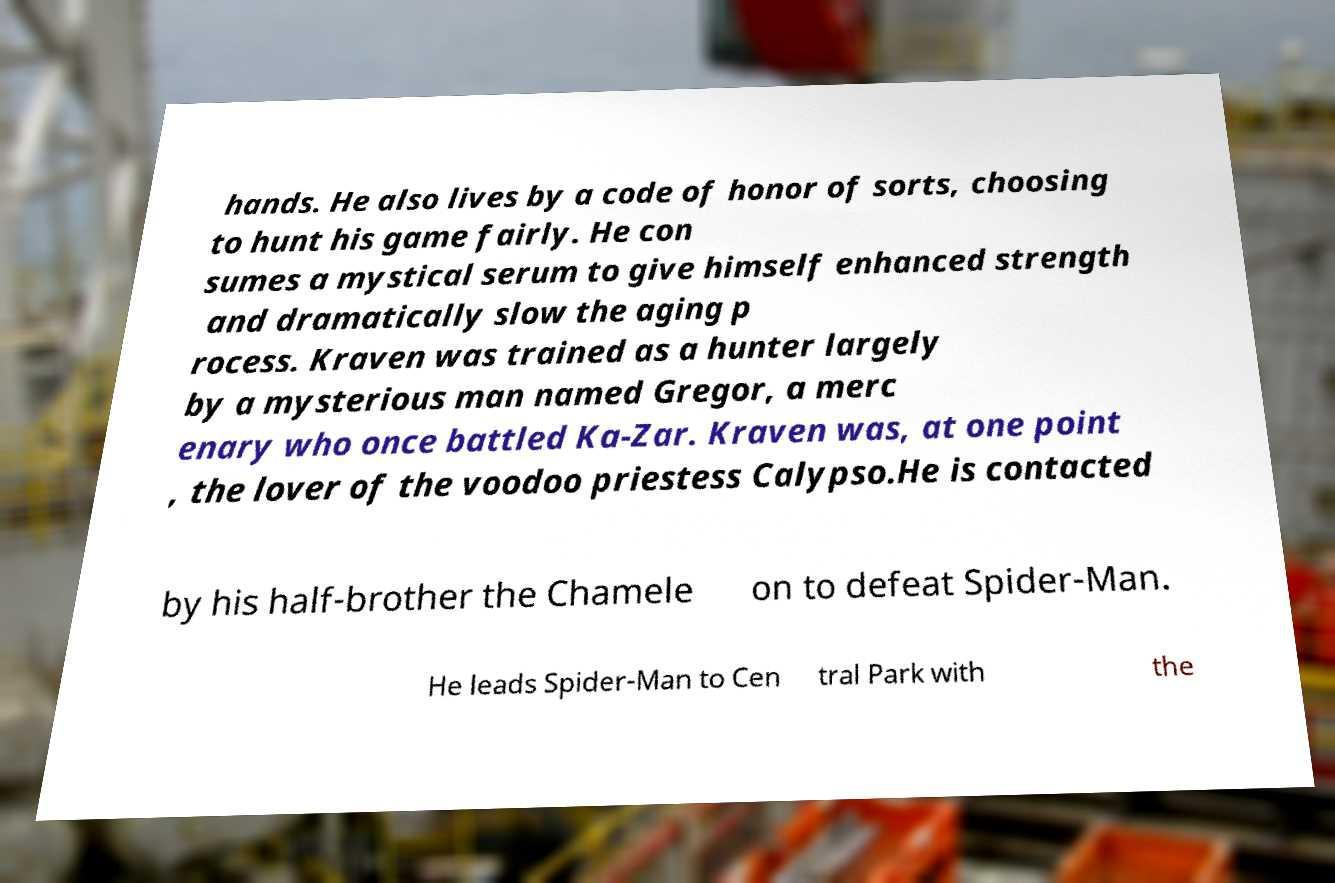Could you assist in decoding the text presented in this image and type it out clearly? hands. He also lives by a code of honor of sorts, choosing to hunt his game fairly. He con sumes a mystical serum to give himself enhanced strength and dramatically slow the aging p rocess. Kraven was trained as a hunter largely by a mysterious man named Gregor, a merc enary who once battled Ka-Zar. Kraven was, at one point , the lover of the voodoo priestess Calypso.He is contacted by his half-brother the Chamele on to defeat Spider-Man. He leads Spider-Man to Cen tral Park with the 